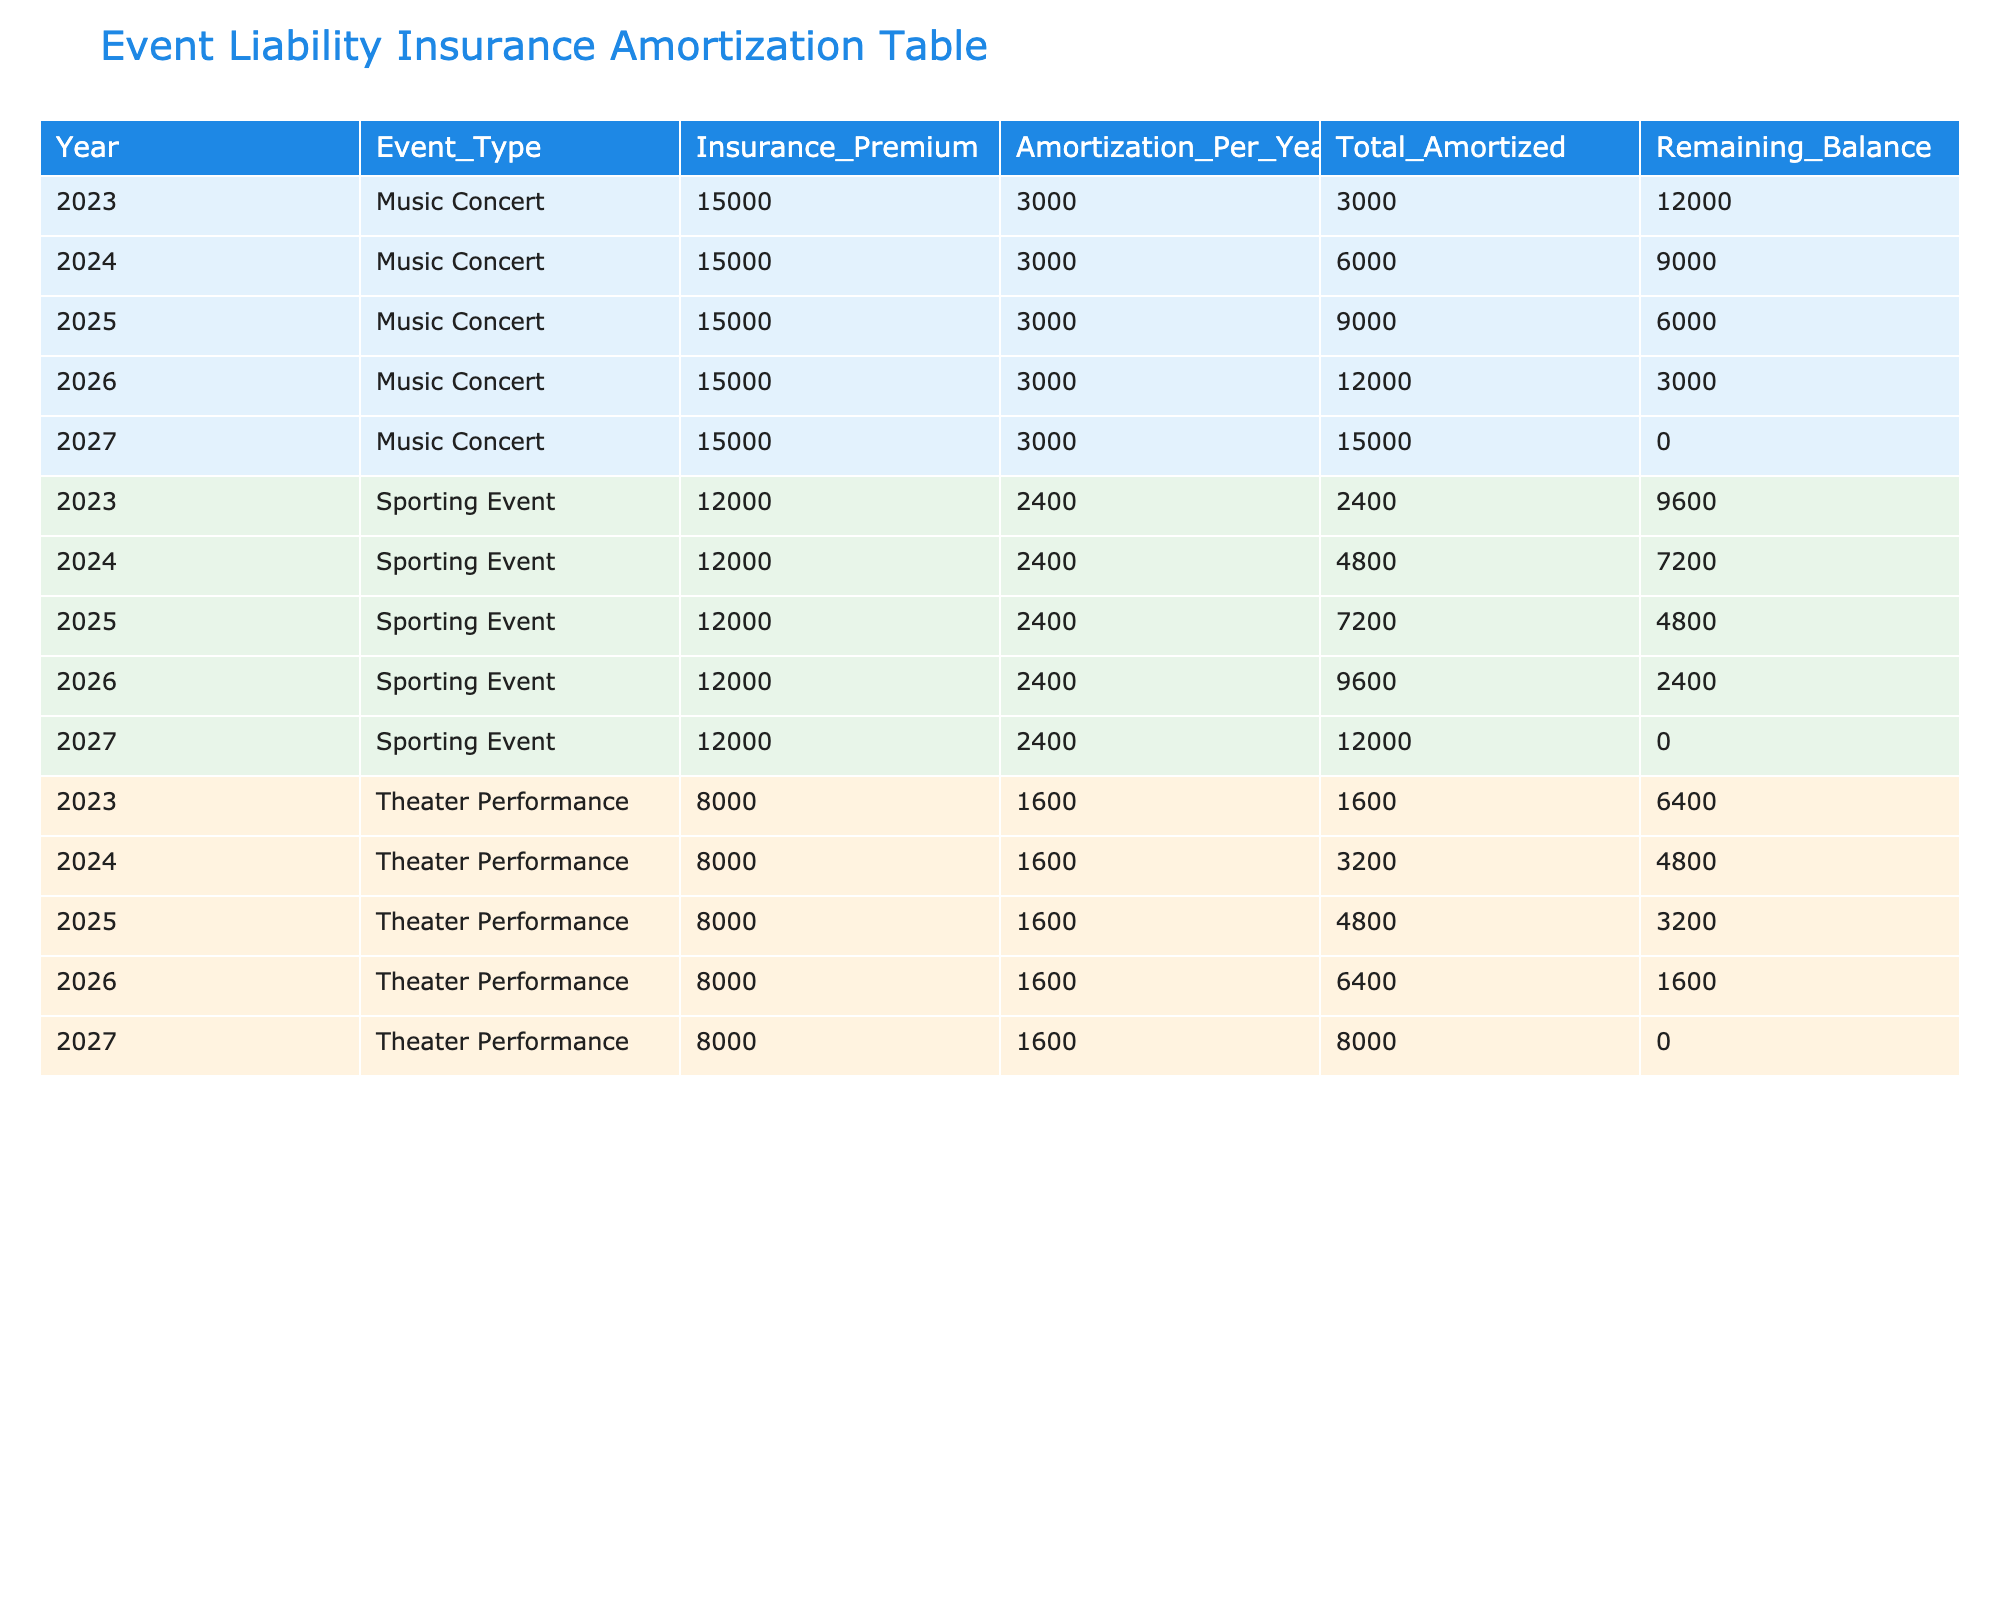What is the total insurance premium for Music Concerts? To find the total insurance premium for Music Concerts, look at the "Insurance_Premium" column for the rows where "Event_Type" is "Music Concert." Each year from 2023 to 2027 has an insurance premium of 15000. Since there are 5 years, the total is calculated as: 15000 * 5 = 75000.
Answer: 75000 How much was the remaining balance for Theater Performances in 2025? The remaining balance for Theater Performances in 2025 can be found in the "Remaining_Balance" column for the row where "Event_Type" is "Theater Performance" and "Year" is 2025. That value is 3200.
Answer: 3200 What is the average annual amortization amount across all event types? To find the average annual amortization, first sum the amortization amounts from the "Amortization_Per_Year" column for all rows: (3000 + 3000 + 3000 + 3000 + 3000) + (1600 + 1600 + 1600 + 1600 + 1600) + (2400 + 2400 + 2400 + 2400 + 2400) = 15000. There are 15 years (5 for each event type), so the average is 15000 / 15 = 1000.
Answer: 1000 Were all sporting events fully amortized by 2027? To determine this, look at the "Remaining_Balance" column for Sporting Events in 2027. The remaining balance is 0, indicating the amortization is complete. This is true for all years leading up to 2027 as the balance decreases to zero.
Answer: Yes What is the total amount amortized for Theater Performances by 2026? To find the total amount amortized for Theater Performances by 2026, sum the "Total_Amortized" values for the years 2023, 2024, 2025, and 2026: 1600 + 3200 + 4800 + 6400 = 16000.
Answer: 16000 What is the difference in total amortization between Music Concerts and Sporting Events in 2027? For Music Concerts in 2027, the total amortized is 15000. For Sporting Events, the total amortized is also 12000. The difference is calculated as 15000 - 12000 = 3000.
Answer: 3000 